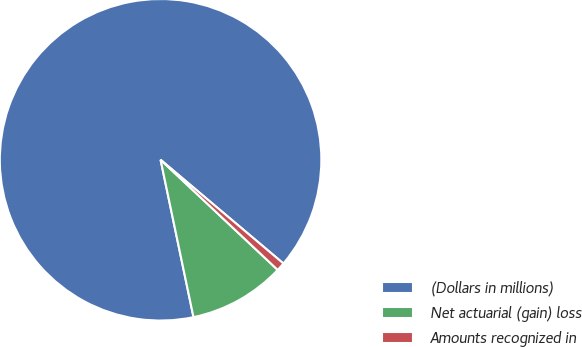Convert chart to OTSL. <chart><loc_0><loc_0><loc_500><loc_500><pie_chart><fcel>(Dollars in millions)<fcel>Net actuarial (gain) loss<fcel>Amounts recognized in<nl><fcel>89.45%<fcel>9.71%<fcel>0.85%<nl></chart> 